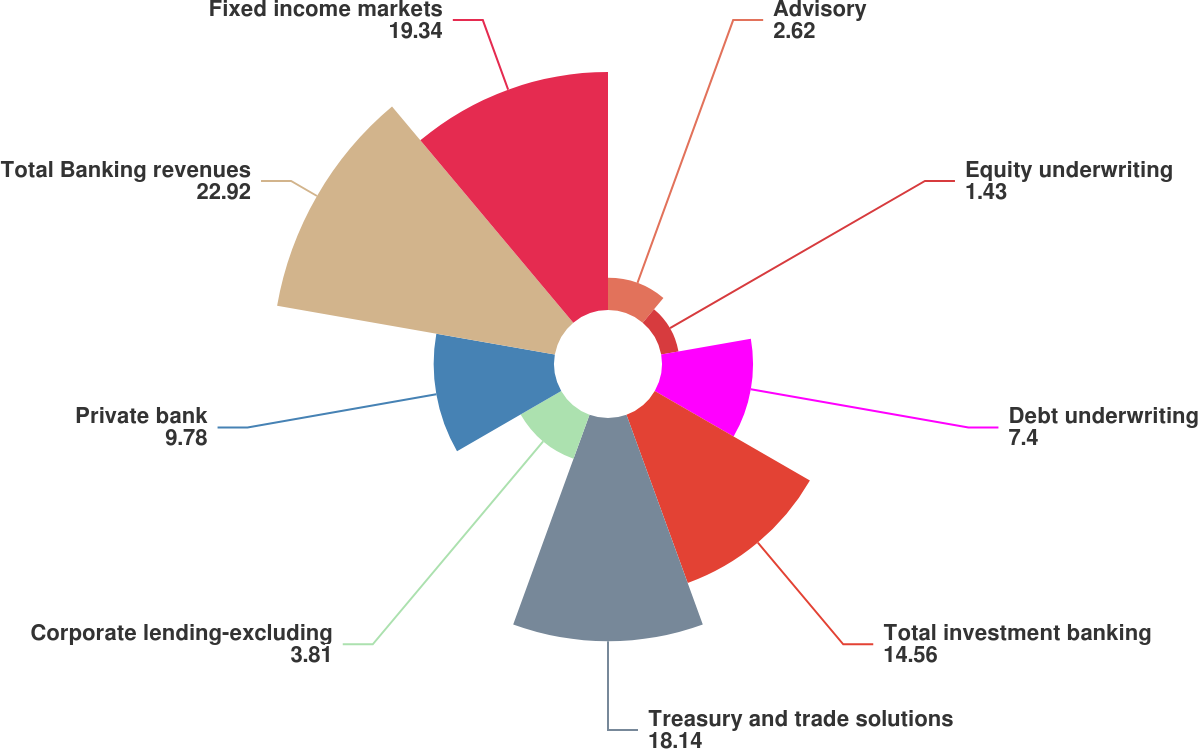Convert chart to OTSL. <chart><loc_0><loc_0><loc_500><loc_500><pie_chart><fcel>Advisory<fcel>Equity underwriting<fcel>Debt underwriting<fcel>Total investment banking<fcel>Treasury and trade solutions<fcel>Corporate lending-excluding<fcel>Private bank<fcel>Total Banking revenues<fcel>Fixed income markets<nl><fcel>2.62%<fcel>1.43%<fcel>7.4%<fcel>14.56%<fcel>18.14%<fcel>3.81%<fcel>9.78%<fcel>22.92%<fcel>19.34%<nl></chart> 